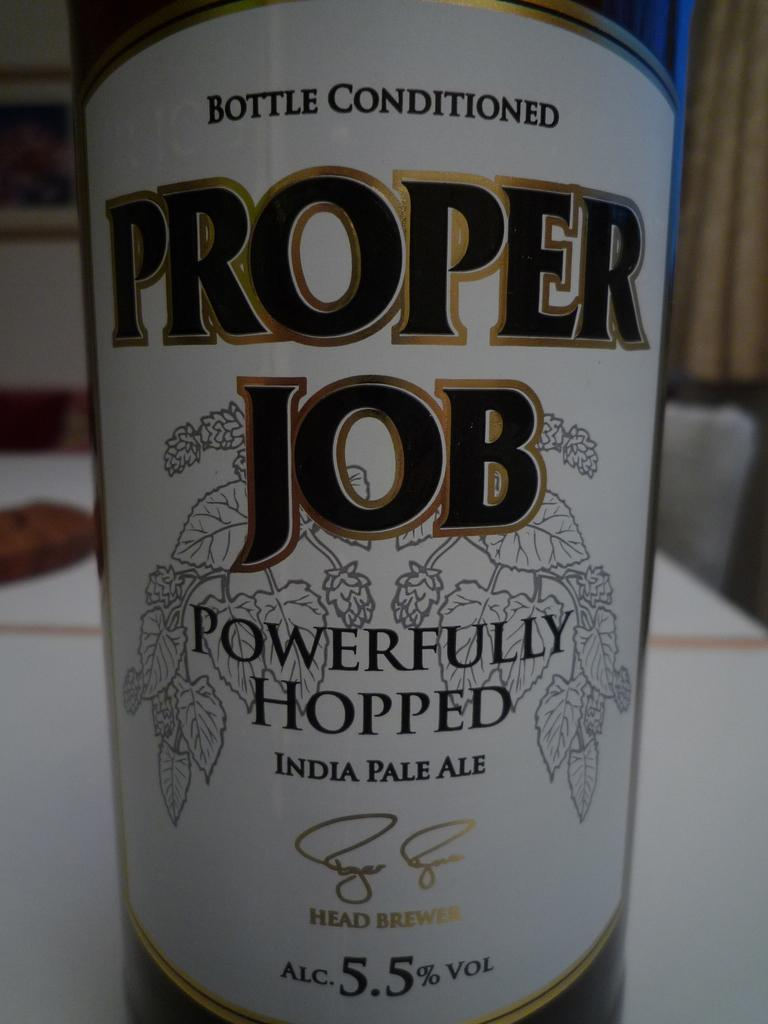What object is placed on the table in the image? There is a bottle on a table in the image. What type of covering is present in the image? There is a curtain in the image. What type of guitar is being played in the image? There is no guitar present in the image; it only features a bottle on a table and a curtain. 